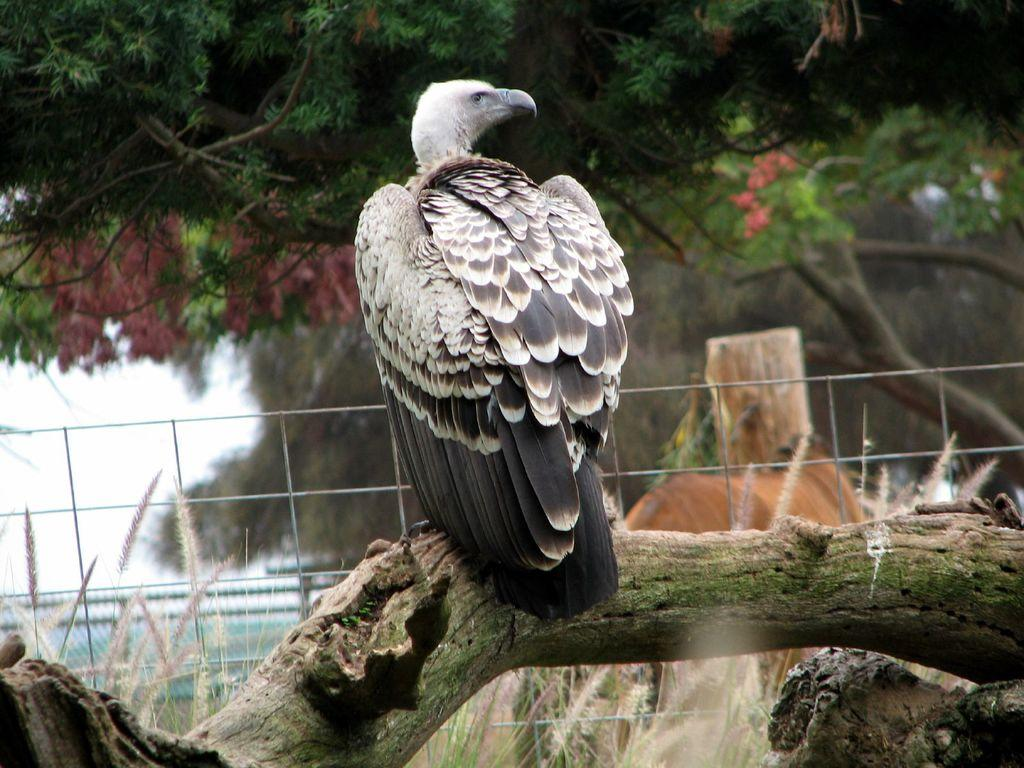What is on the bark of the tree in the image? There is a bird on the bark of a tree in the image. Where is the bird located in relation to the image? The bird is in the middle of the image. What can be seen in the background of the image? There are trees in the background of the image. What is your sister observing on the mountain in the image? There is no mountain or sister present in the image; it features a bird on a tree. 